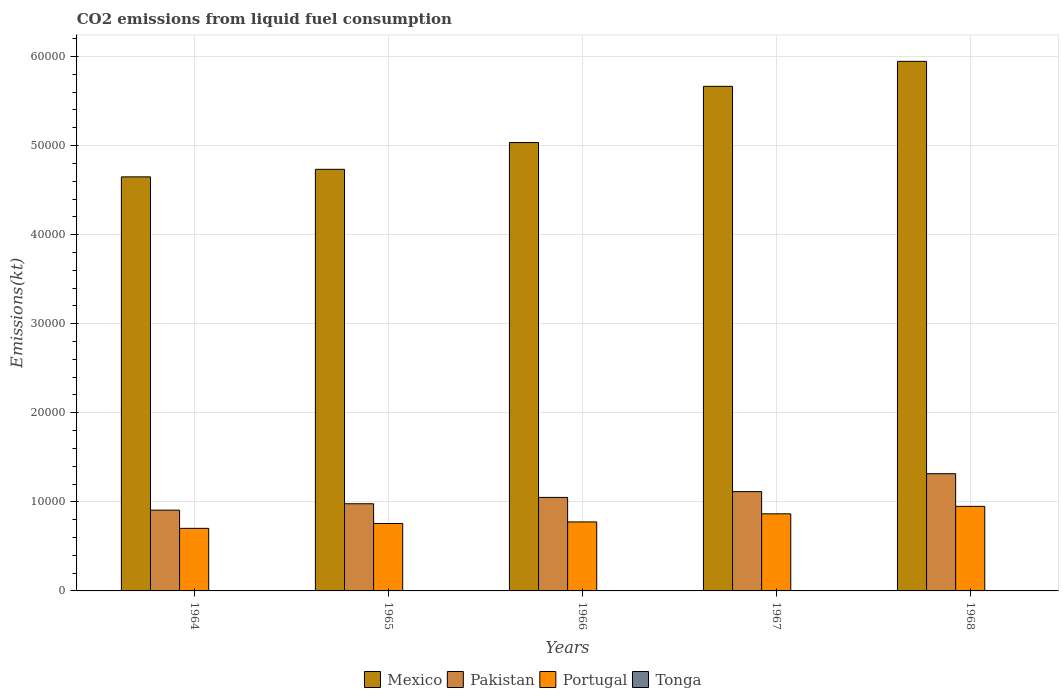How many different coloured bars are there?
Provide a succinct answer. 4. Are the number of bars per tick equal to the number of legend labels?
Offer a very short reply. Yes. Are the number of bars on each tick of the X-axis equal?
Provide a succinct answer. Yes. What is the label of the 3rd group of bars from the left?
Your response must be concise. 1966. In how many cases, is the number of bars for a given year not equal to the number of legend labels?
Give a very brief answer. 0. What is the amount of CO2 emitted in Pakistan in 1968?
Your response must be concise. 1.32e+04. Across all years, what is the maximum amount of CO2 emitted in Mexico?
Your answer should be very brief. 5.95e+04. Across all years, what is the minimum amount of CO2 emitted in Portugal?
Offer a terse response. 7025.97. In which year was the amount of CO2 emitted in Portugal maximum?
Provide a short and direct response. 1968. In which year was the amount of CO2 emitted in Pakistan minimum?
Your answer should be very brief. 1964. What is the total amount of CO2 emitted in Pakistan in the graph?
Offer a terse response. 5.37e+04. What is the difference between the amount of CO2 emitted in Tonga in 1964 and that in 1966?
Offer a terse response. 0. What is the difference between the amount of CO2 emitted in Tonga in 1968 and the amount of CO2 emitted in Mexico in 1964?
Offer a very short reply. -4.65e+04. What is the average amount of CO2 emitted in Mexico per year?
Provide a short and direct response. 5.21e+04. In the year 1967, what is the difference between the amount of CO2 emitted in Mexico and amount of CO2 emitted in Portugal?
Provide a succinct answer. 4.80e+04. In how many years, is the amount of CO2 emitted in Tonga greater than 52000 kt?
Your answer should be very brief. 0. What is the ratio of the amount of CO2 emitted in Mexico in 1966 to that in 1968?
Make the answer very short. 0.85. Is the amount of CO2 emitted in Portugal in 1965 less than that in 1966?
Your response must be concise. Yes. What is the difference between the highest and the second highest amount of CO2 emitted in Pakistan?
Give a very brief answer. 2013.18. What is the difference between the highest and the lowest amount of CO2 emitted in Pakistan?
Provide a short and direct response. 4096.04. In how many years, is the amount of CO2 emitted in Portugal greater than the average amount of CO2 emitted in Portugal taken over all years?
Make the answer very short. 2. What does the 4th bar from the left in 1968 represents?
Your response must be concise. Tonga. What does the 4th bar from the right in 1965 represents?
Give a very brief answer. Mexico. How many years are there in the graph?
Ensure brevity in your answer.  5. What is the difference between two consecutive major ticks on the Y-axis?
Your answer should be compact. 10000. Are the values on the major ticks of Y-axis written in scientific E-notation?
Provide a succinct answer. No. Does the graph contain grids?
Ensure brevity in your answer.  Yes. Where does the legend appear in the graph?
Your answer should be very brief. Bottom center. What is the title of the graph?
Provide a succinct answer. CO2 emissions from liquid fuel consumption. What is the label or title of the Y-axis?
Offer a terse response. Emissions(kt). What is the Emissions(kt) in Mexico in 1964?
Keep it short and to the point. 4.65e+04. What is the Emissions(kt) of Pakistan in 1964?
Ensure brevity in your answer.  9068.49. What is the Emissions(kt) of Portugal in 1964?
Provide a succinct answer. 7025.97. What is the Emissions(kt) of Tonga in 1964?
Make the answer very short. 11. What is the Emissions(kt) in Mexico in 1965?
Offer a terse response. 4.73e+04. What is the Emissions(kt) in Pakistan in 1965?
Provide a short and direct response. 9787.22. What is the Emissions(kt) of Portugal in 1965?
Keep it short and to the point. 7568.69. What is the Emissions(kt) of Tonga in 1965?
Your answer should be compact. 11. What is the Emissions(kt) of Mexico in 1966?
Your answer should be very brief. 5.03e+04. What is the Emissions(kt) of Pakistan in 1966?
Make the answer very short. 1.05e+04. What is the Emissions(kt) in Portugal in 1966?
Your answer should be very brief. 7748.37. What is the Emissions(kt) in Tonga in 1966?
Offer a very short reply. 11. What is the Emissions(kt) in Mexico in 1967?
Your response must be concise. 5.67e+04. What is the Emissions(kt) of Pakistan in 1967?
Give a very brief answer. 1.12e+04. What is the Emissions(kt) in Portugal in 1967?
Make the answer very short. 8657.79. What is the Emissions(kt) of Tonga in 1967?
Keep it short and to the point. 14.67. What is the Emissions(kt) in Mexico in 1968?
Give a very brief answer. 5.95e+04. What is the Emissions(kt) in Pakistan in 1968?
Offer a terse response. 1.32e+04. What is the Emissions(kt) of Portugal in 1968?
Provide a succinct answer. 9493.86. What is the Emissions(kt) of Tonga in 1968?
Keep it short and to the point. 14.67. Across all years, what is the maximum Emissions(kt) of Mexico?
Your response must be concise. 5.95e+04. Across all years, what is the maximum Emissions(kt) of Pakistan?
Provide a succinct answer. 1.32e+04. Across all years, what is the maximum Emissions(kt) of Portugal?
Your answer should be very brief. 9493.86. Across all years, what is the maximum Emissions(kt) of Tonga?
Offer a very short reply. 14.67. Across all years, what is the minimum Emissions(kt) of Mexico?
Make the answer very short. 4.65e+04. Across all years, what is the minimum Emissions(kt) in Pakistan?
Your answer should be compact. 9068.49. Across all years, what is the minimum Emissions(kt) of Portugal?
Offer a very short reply. 7025.97. Across all years, what is the minimum Emissions(kt) of Tonga?
Offer a very short reply. 11. What is the total Emissions(kt) in Mexico in the graph?
Ensure brevity in your answer.  2.60e+05. What is the total Emissions(kt) in Pakistan in the graph?
Provide a succinct answer. 5.37e+04. What is the total Emissions(kt) in Portugal in the graph?
Your answer should be very brief. 4.05e+04. What is the total Emissions(kt) of Tonga in the graph?
Your response must be concise. 62.34. What is the difference between the Emissions(kt) of Mexico in 1964 and that in 1965?
Offer a very short reply. -847.08. What is the difference between the Emissions(kt) of Pakistan in 1964 and that in 1965?
Your response must be concise. -718.73. What is the difference between the Emissions(kt) in Portugal in 1964 and that in 1965?
Your answer should be compact. -542.72. What is the difference between the Emissions(kt) in Tonga in 1964 and that in 1965?
Your answer should be very brief. 0. What is the difference between the Emissions(kt) of Mexico in 1964 and that in 1966?
Your answer should be very brief. -3854.02. What is the difference between the Emissions(kt) in Pakistan in 1964 and that in 1966?
Keep it short and to the point. -1430.13. What is the difference between the Emissions(kt) of Portugal in 1964 and that in 1966?
Ensure brevity in your answer.  -722.4. What is the difference between the Emissions(kt) of Tonga in 1964 and that in 1966?
Ensure brevity in your answer.  0. What is the difference between the Emissions(kt) of Mexico in 1964 and that in 1967?
Your answer should be very brief. -1.02e+04. What is the difference between the Emissions(kt) in Pakistan in 1964 and that in 1967?
Provide a succinct answer. -2082.86. What is the difference between the Emissions(kt) of Portugal in 1964 and that in 1967?
Provide a succinct answer. -1631.82. What is the difference between the Emissions(kt) in Tonga in 1964 and that in 1967?
Give a very brief answer. -3.67. What is the difference between the Emissions(kt) in Mexico in 1964 and that in 1968?
Provide a succinct answer. -1.30e+04. What is the difference between the Emissions(kt) of Pakistan in 1964 and that in 1968?
Make the answer very short. -4096.04. What is the difference between the Emissions(kt) of Portugal in 1964 and that in 1968?
Your response must be concise. -2467.89. What is the difference between the Emissions(kt) in Tonga in 1964 and that in 1968?
Provide a short and direct response. -3.67. What is the difference between the Emissions(kt) in Mexico in 1965 and that in 1966?
Your response must be concise. -3006.94. What is the difference between the Emissions(kt) of Pakistan in 1965 and that in 1966?
Give a very brief answer. -711.4. What is the difference between the Emissions(kt) in Portugal in 1965 and that in 1966?
Your answer should be very brief. -179.68. What is the difference between the Emissions(kt) of Mexico in 1965 and that in 1967?
Offer a very short reply. -9317.85. What is the difference between the Emissions(kt) of Pakistan in 1965 and that in 1967?
Offer a very short reply. -1364.12. What is the difference between the Emissions(kt) in Portugal in 1965 and that in 1967?
Your answer should be very brief. -1089.1. What is the difference between the Emissions(kt) of Tonga in 1965 and that in 1967?
Provide a succinct answer. -3.67. What is the difference between the Emissions(kt) in Mexico in 1965 and that in 1968?
Provide a succinct answer. -1.21e+04. What is the difference between the Emissions(kt) in Pakistan in 1965 and that in 1968?
Give a very brief answer. -3377.31. What is the difference between the Emissions(kt) of Portugal in 1965 and that in 1968?
Your response must be concise. -1925.17. What is the difference between the Emissions(kt) in Tonga in 1965 and that in 1968?
Offer a terse response. -3.67. What is the difference between the Emissions(kt) of Mexico in 1966 and that in 1967?
Provide a succinct answer. -6310.91. What is the difference between the Emissions(kt) of Pakistan in 1966 and that in 1967?
Offer a very short reply. -652.73. What is the difference between the Emissions(kt) of Portugal in 1966 and that in 1967?
Give a very brief answer. -909.42. What is the difference between the Emissions(kt) in Tonga in 1966 and that in 1967?
Provide a short and direct response. -3.67. What is the difference between the Emissions(kt) in Mexico in 1966 and that in 1968?
Keep it short and to the point. -9116.16. What is the difference between the Emissions(kt) of Pakistan in 1966 and that in 1968?
Your answer should be very brief. -2665.91. What is the difference between the Emissions(kt) in Portugal in 1966 and that in 1968?
Your response must be concise. -1745.49. What is the difference between the Emissions(kt) of Tonga in 1966 and that in 1968?
Provide a succinct answer. -3.67. What is the difference between the Emissions(kt) of Mexico in 1967 and that in 1968?
Make the answer very short. -2805.26. What is the difference between the Emissions(kt) in Pakistan in 1967 and that in 1968?
Ensure brevity in your answer.  -2013.18. What is the difference between the Emissions(kt) of Portugal in 1967 and that in 1968?
Offer a very short reply. -836.08. What is the difference between the Emissions(kt) of Tonga in 1967 and that in 1968?
Give a very brief answer. 0. What is the difference between the Emissions(kt) of Mexico in 1964 and the Emissions(kt) of Pakistan in 1965?
Your response must be concise. 3.67e+04. What is the difference between the Emissions(kt) of Mexico in 1964 and the Emissions(kt) of Portugal in 1965?
Your response must be concise. 3.89e+04. What is the difference between the Emissions(kt) in Mexico in 1964 and the Emissions(kt) in Tonga in 1965?
Provide a succinct answer. 4.65e+04. What is the difference between the Emissions(kt) in Pakistan in 1964 and the Emissions(kt) in Portugal in 1965?
Your answer should be compact. 1499.8. What is the difference between the Emissions(kt) in Pakistan in 1964 and the Emissions(kt) in Tonga in 1965?
Offer a very short reply. 9057.49. What is the difference between the Emissions(kt) of Portugal in 1964 and the Emissions(kt) of Tonga in 1965?
Offer a terse response. 7014.97. What is the difference between the Emissions(kt) of Mexico in 1964 and the Emissions(kt) of Pakistan in 1966?
Your answer should be very brief. 3.60e+04. What is the difference between the Emissions(kt) in Mexico in 1964 and the Emissions(kt) in Portugal in 1966?
Provide a short and direct response. 3.87e+04. What is the difference between the Emissions(kt) in Mexico in 1964 and the Emissions(kt) in Tonga in 1966?
Ensure brevity in your answer.  4.65e+04. What is the difference between the Emissions(kt) in Pakistan in 1964 and the Emissions(kt) in Portugal in 1966?
Offer a terse response. 1320.12. What is the difference between the Emissions(kt) in Pakistan in 1964 and the Emissions(kt) in Tonga in 1966?
Ensure brevity in your answer.  9057.49. What is the difference between the Emissions(kt) in Portugal in 1964 and the Emissions(kt) in Tonga in 1966?
Your answer should be compact. 7014.97. What is the difference between the Emissions(kt) of Mexico in 1964 and the Emissions(kt) of Pakistan in 1967?
Your response must be concise. 3.53e+04. What is the difference between the Emissions(kt) of Mexico in 1964 and the Emissions(kt) of Portugal in 1967?
Your response must be concise. 3.78e+04. What is the difference between the Emissions(kt) in Mexico in 1964 and the Emissions(kt) in Tonga in 1967?
Offer a very short reply. 4.65e+04. What is the difference between the Emissions(kt) of Pakistan in 1964 and the Emissions(kt) of Portugal in 1967?
Your answer should be compact. 410.7. What is the difference between the Emissions(kt) in Pakistan in 1964 and the Emissions(kt) in Tonga in 1967?
Your response must be concise. 9053.82. What is the difference between the Emissions(kt) of Portugal in 1964 and the Emissions(kt) of Tonga in 1967?
Make the answer very short. 7011.3. What is the difference between the Emissions(kt) in Mexico in 1964 and the Emissions(kt) in Pakistan in 1968?
Make the answer very short. 3.33e+04. What is the difference between the Emissions(kt) in Mexico in 1964 and the Emissions(kt) in Portugal in 1968?
Provide a short and direct response. 3.70e+04. What is the difference between the Emissions(kt) in Mexico in 1964 and the Emissions(kt) in Tonga in 1968?
Provide a short and direct response. 4.65e+04. What is the difference between the Emissions(kt) in Pakistan in 1964 and the Emissions(kt) in Portugal in 1968?
Make the answer very short. -425.37. What is the difference between the Emissions(kt) in Pakistan in 1964 and the Emissions(kt) in Tonga in 1968?
Provide a succinct answer. 9053.82. What is the difference between the Emissions(kt) of Portugal in 1964 and the Emissions(kt) of Tonga in 1968?
Your answer should be very brief. 7011.3. What is the difference between the Emissions(kt) in Mexico in 1965 and the Emissions(kt) in Pakistan in 1966?
Offer a terse response. 3.68e+04. What is the difference between the Emissions(kt) in Mexico in 1965 and the Emissions(kt) in Portugal in 1966?
Offer a very short reply. 3.96e+04. What is the difference between the Emissions(kt) of Mexico in 1965 and the Emissions(kt) of Tonga in 1966?
Give a very brief answer. 4.73e+04. What is the difference between the Emissions(kt) in Pakistan in 1965 and the Emissions(kt) in Portugal in 1966?
Your response must be concise. 2038.85. What is the difference between the Emissions(kt) in Pakistan in 1965 and the Emissions(kt) in Tonga in 1966?
Provide a short and direct response. 9776.22. What is the difference between the Emissions(kt) in Portugal in 1965 and the Emissions(kt) in Tonga in 1966?
Provide a succinct answer. 7557.69. What is the difference between the Emissions(kt) of Mexico in 1965 and the Emissions(kt) of Pakistan in 1967?
Ensure brevity in your answer.  3.62e+04. What is the difference between the Emissions(kt) of Mexico in 1965 and the Emissions(kt) of Portugal in 1967?
Provide a short and direct response. 3.87e+04. What is the difference between the Emissions(kt) in Mexico in 1965 and the Emissions(kt) in Tonga in 1967?
Your response must be concise. 4.73e+04. What is the difference between the Emissions(kt) of Pakistan in 1965 and the Emissions(kt) of Portugal in 1967?
Offer a very short reply. 1129.44. What is the difference between the Emissions(kt) of Pakistan in 1965 and the Emissions(kt) of Tonga in 1967?
Your answer should be very brief. 9772.56. What is the difference between the Emissions(kt) of Portugal in 1965 and the Emissions(kt) of Tonga in 1967?
Your response must be concise. 7554.02. What is the difference between the Emissions(kt) in Mexico in 1965 and the Emissions(kt) in Pakistan in 1968?
Your answer should be very brief. 3.42e+04. What is the difference between the Emissions(kt) of Mexico in 1965 and the Emissions(kt) of Portugal in 1968?
Offer a terse response. 3.78e+04. What is the difference between the Emissions(kt) of Mexico in 1965 and the Emissions(kt) of Tonga in 1968?
Offer a terse response. 4.73e+04. What is the difference between the Emissions(kt) of Pakistan in 1965 and the Emissions(kt) of Portugal in 1968?
Offer a very short reply. 293.36. What is the difference between the Emissions(kt) in Pakistan in 1965 and the Emissions(kt) in Tonga in 1968?
Your response must be concise. 9772.56. What is the difference between the Emissions(kt) of Portugal in 1965 and the Emissions(kt) of Tonga in 1968?
Give a very brief answer. 7554.02. What is the difference between the Emissions(kt) in Mexico in 1966 and the Emissions(kt) in Pakistan in 1967?
Your answer should be compact. 3.92e+04. What is the difference between the Emissions(kt) in Mexico in 1966 and the Emissions(kt) in Portugal in 1967?
Keep it short and to the point. 4.17e+04. What is the difference between the Emissions(kt) of Mexico in 1966 and the Emissions(kt) of Tonga in 1967?
Your answer should be very brief. 5.03e+04. What is the difference between the Emissions(kt) in Pakistan in 1966 and the Emissions(kt) in Portugal in 1967?
Provide a succinct answer. 1840.83. What is the difference between the Emissions(kt) in Pakistan in 1966 and the Emissions(kt) in Tonga in 1967?
Your answer should be compact. 1.05e+04. What is the difference between the Emissions(kt) in Portugal in 1966 and the Emissions(kt) in Tonga in 1967?
Provide a succinct answer. 7733.7. What is the difference between the Emissions(kt) of Mexico in 1966 and the Emissions(kt) of Pakistan in 1968?
Keep it short and to the point. 3.72e+04. What is the difference between the Emissions(kt) of Mexico in 1966 and the Emissions(kt) of Portugal in 1968?
Your answer should be compact. 4.09e+04. What is the difference between the Emissions(kt) of Mexico in 1966 and the Emissions(kt) of Tonga in 1968?
Give a very brief answer. 5.03e+04. What is the difference between the Emissions(kt) of Pakistan in 1966 and the Emissions(kt) of Portugal in 1968?
Keep it short and to the point. 1004.76. What is the difference between the Emissions(kt) in Pakistan in 1966 and the Emissions(kt) in Tonga in 1968?
Provide a succinct answer. 1.05e+04. What is the difference between the Emissions(kt) in Portugal in 1966 and the Emissions(kt) in Tonga in 1968?
Ensure brevity in your answer.  7733.7. What is the difference between the Emissions(kt) of Mexico in 1967 and the Emissions(kt) of Pakistan in 1968?
Provide a succinct answer. 4.35e+04. What is the difference between the Emissions(kt) of Mexico in 1967 and the Emissions(kt) of Portugal in 1968?
Your answer should be very brief. 4.72e+04. What is the difference between the Emissions(kt) in Mexico in 1967 and the Emissions(kt) in Tonga in 1968?
Offer a very short reply. 5.66e+04. What is the difference between the Emissions(kt) in Pakistan in 1967 and the Emissions(kt) in Portugal in 1968?
Keep it short and to the point. 1657.48. What is the difference between the Emissions(kt) in Pakistan in 1967 and the Emissions(kt) in Tonga in 1968?
Ensure brevity in your answer.  1.11e+04. What is the difference between the Emissions(kt) in Portugal in 1967 and the Emissions(kt) in Tonga in 1968?
Offer a very short reply. 8643.12. What is the average Emissions(kt) in Mexico per year?
Provide a short and direct response. 5.21e+04. What is the average Emissions(kt) of Pakistan per year?
Ensure brevity in your answer.  1.07e+04. What is the average Emissions(kt) in Portugal per year?
Keep it short and to the point. 8098.94. What is the average Emissions(kt) of Tonga per year?
Provide a short and direct response. 12.47. In the year 1964, what is the difference between the Emissions(kt) in Mexico and Emissions(kt) in Pakistan?
Your response must be concise. 3.74e+04. In the year 1964, what is the difference between the Emissions(kt) in Mexico and Emissions(kt) in Portugal?
Make the answer very short. 3.95e+04. In the year 1964, what is the difference between the Emissions(kt) in Mexico and Emissions(kt) in Tonga?
Provide a succinct answer. 4.65e+04. In the year 1964, what is the difference between the Emissions(kt) in Pakistan and Emissions(kt) in Portugal?
Ensure brevity in your answer.  2042.52. In the year 1964, what is the difference between the Emissions(kt) in Pakistan and Emissions(kt) in Tonga?
Provide a short and direct response. 9057.49. In the year 1964, what is the difference between the Emissions(kt) of Portugal and Emissions(kt) of Tonga?
Your answer should be compact. 7014.97. In the year 1965, what is the difference between the Emissions(kt) of Mexico and Emissions(kt) of Pakistan?
Ensure brevity in your answer.  3.76e+04. In the year 1965, what is the difference between the Emissions(kt) in Mexico and Emissions(kt) in Portugal?
Offer a very short reply. 3.98e+04. In the year 1965, what is the difference between the Emissions(kt) of Mexico and Emissions(kt) of Tonga?
Keep it short and to the point. 4.73e+04. In the year 1965, what is the difference between the Emissions(kt) in Pakistan and Emissions(kt) in Portugal?
Ensure brevity in your answer.  2218.53. In the year 1965, what is the difference between the Emissions(kt) of Pakistan and Emissions(kt) of Tonga?
Your response must be concise. 9776.22. In the year 1965, what is the difference between the Emissions(kt) in Portugal and Emissions(kt) in Tonga?
Your answer should be compact. 7557.69. In the year 1966, what is the difference between the Emissions(kt) in Mexico and Emissions(kt) in Pakistan?
Provide a succinct answer. 3.98e+04. In the year 1966, what is the difference between the Emissions(kt) of Mexico and Emissions(kt) of Portugal?
Give a very brief answer. 4.26e+04. In the year 1966, what is the difference between the Emissions(kt) of Mexico and Emissions(kt) of Tonga?
Offer a very short reply. 5.03e+04. In the year 1966, what is the difference between the Emissions(kt) of Pakistan and Emissions(kt) of Portugal?
Offer a very short reply. 2750.25. In the year 1966, what is the difference between the Emissions(kt) of Pakistan and Emissions(kt) of Tonga?
Ensure brevity in your answer.  1.05e+04. In the year 1966, what is the difference between the Emissions(kt) of Portugal and Emissions(kt) of Tonga?
Your response must be concise. 7737.37. In the year 1967, what is the difference between the Emissions(kt) in Mexico and Emissions(kt) in Pakistan?
Make the answer very short. 4.55e+04. In the year 1967, what is the difference between the Emissions(kt) of Mexico and Emissions(kt) of Portugal?
Keep it short and to the point. 4.80e+04. In the year 1967, what is the difference between the Emissions(kt) of Mexico and Emissions(kt) of Tonga?
Provide a short and direct response. 5.66e+04. In the year 1967, what is the difference between the Emissions(kt) of Pakistan and Emissions(kt) of Portugal?
Your response must be concise. 2493.56. In the year 1967, what is the difference between the Emissions(kt) of Pakistan and Emissions(kt) of Tonga?
Make the answer very short. 1.11e+04. In the year 1967, what is the difference between the Emissions(kt) of Portugal and Emissions(kt) of Tonga?
Offer a terse response. 8643.12. In the year 1968, what is the difference between the Emissions(kt) in Mexico and Emissions(kt) in Pakistan?
Offer a terse response. 4.63e+04. In the year 1968, what is the difference between the Emissions(kt) in Mexico and Emissions(kt) in Portugal?
Offer a terse response. 5.00e+04. In the year 1968, what is the difference between the Emissions(kt) in Mexico and Emissions(kt) in Tonga?
Your answer should be compact. 5.94e+04. In the year 1968, what is the difference between the Emissions(kt) of Pakistan and Emissions(kt) of Portugal?
Offer a terse response. 3670.67. In the year 1968, what is the difference between the Emissions(kt) in Pakistan and Emissions(kt) in Tonga?
Your answer should be compact. 1.31e+04. In the year 1968, what is the difference between the Emissions(kt) of Portugal and Emissions(kt) of Tonga?
Offer a terse response. 9479.19. What is the ratio of the Emissions(kt) of Mexico in 1964 to that in 1965?
Your response must be concise. 0.98. What is the ratio of the Emissions(kt) in Pakistan in 1964 to that in 1965?
Make the answer very short. 0.93. What is the ratio of the Emissions(kt) in Portugal in 1964 to that in 1965?
Your answer should be very brief. 0.93. What is the ratio of the Emissions(kt) in Mexico in 1964 to that in 1966?
Keep it short and to the point. 0.92. What is the ratio of the Emissions(kt) in Pakistan in 1964 to that in 1966?
Your response must be concise. 0.86. What is the ratio of the Emissions(kt) in Portugal in 1964 to that in 1966?
Make the answer very short. 0.91. What is the ratio of the Emissions(kt) of Tonga in 1964 to that in 1966?
Your answer should be very brief. 1. What is the ratio of the Emissions(kt) of Mexico in 1964 to that in 1967?
Your answer should be compact. 0.82. What is the ratio of the Emissions(kt) in Pakistan in 1964 to that in 1967?
Your answer should be very brief. 0.81. What is the ratio of the Emissions(kt) in Portugal in 1964 to that in 1967?
Ensure brevity in your answer.  0.81. What is the ratio of the Emissions(kt) of Tonga in 1964 to that in 1967?
Offer a terse response. 0.75. What is the ratio of the Emissions(kt) in Mexico in 1964 to that in 1968?
Ensure brevity in your answer.  0.78. What is the ratio of the Emissions(kt) of Pakistan in 1964 to that in 1968?
Provide a short and direct response. 0.69. What is the ratio of the Emissions(kt) of Portugal in 1964 to that in 1968?
Ensure brevity in your answer.  0.74. What is the ratio of the Emissions(kt) of Mexico in 1965 to that in 1966?
Your response must be concise. 0.94. What is the ratio of the Emissions(kt) of Pakistan in 1965 to that in 1966?
Offer a very short reply. 0.93. What is the ratio of the Emissions(kt) in Portugal in 1965 to that in 1966?
Provide a short and direct response. 0.98. What is the ratio of the Emissions(kt) of Tonga in 1965 to that in 1966?
Your answer should be very brief. 1. What is the ratio of the Emissions(kt) of Mexico in 1965 to that in 1967?
Provide a short and direct response. 0.84. What is the ratio of the Emissions(kt) of Pakistan in 1965 to that in 1967?
Your answer should be very brief. 0.88. What is the ratio of the Emissions(kt) in Portugal in 1965 to that in 1967?
Your answer should be very brief. 0.87. What is the ratio of the Emissions(kt) in Tonga in 1965 to that in 1967?
Keep it short and to the point. 0.75. What is the ratio of the Emissions(kt) of Mexico in 1965 to that in 1968?
Your answer should be compact. 0.8. What is the ratio of the Emissions(kt) of Pakistan in 1965 to that in 1968?
Ensure brevity in your answer.  0.74. What is the ratio of the Emissions(kt) of Portugal in 1965 to that in 1968?
Provide a succinct answer. 0.8. What is the ratio of the Emissions(kt) in Tonga in 1965 to that in 1968?
Ensure brevity in your answer.  0.75. What is the ratio of the Emissions(kt) of Mexico in 1966 to that in 1967?
Provide a succinct answer. 0.89. What is the ratio of the Emissions(kt) in Pakistan in 1966 to that in 1967?
Provide a short and direct response. 0.94. What is the ratio of the Emissions(kt) in Portugal in 1966 to that in 1967?
Offer a very short reply. 0.9. What is the ratio of the Emissions(kt) of Tonga in 1966 to that in 1967?
Give a very brief answer. 0.75. What is the ratio of the Emissions(kt) in Mexico in 1966 to that in 1968?
Offer a terse response. 0.85. What is the ratio of the Emissions(kt) of Pakistan in 1966 to that in 1968?
Keep it short and to the point. 0.8. What is the ratio of the Emissions(kt) in Portugal in 1966 to that in 1968?
Offer a very short reply. 0.82. What is the ratio of the Emissions(kt) in Mexico in 1967 to that in 1968?
Give a very brief answer. 0.95. What is the ratio of the Emissions(kt) in Pakistan in 1967 to that in 1968?
Your answer should be compact. 0.85. What is the ratio of the Emissions(kt) of Portugal in 1967 to that in 1968?
Your response must be concise. 0.91. What is the ratio of the Emissions(kt) in Tonga in 1967 to that in 1968?
Give a very brief answer. 1. What is the difference between the highest and the second highest Emissions(kt) of Mexico?
Make the answer very short. 2805.26. What is the difference between the highest and the second highest Emissions(kt) of Pakistan?
Offer a very short reply. 2013.18. What is the difference between the highest and the second highest Emissions(kt) of Portugal?
Give a very brief answer. 836.08. What is the difference between the highest and the lowest Emissions(kt) in Mexico?
Give a very brief answer. 1.30e+04. What is the difference between the highest and the lowest Emissions(kt) in Pakistan?
Offer a very short reply. 4096.04. What is the difference between the highest and the lowest Emissions(kt) of Portugal?
Provide a succinct answer. 2467.89. What is the difference between the highest and the lowest Emissions(kt) in Tonga?
Provide a succinct answer. 3.67. 